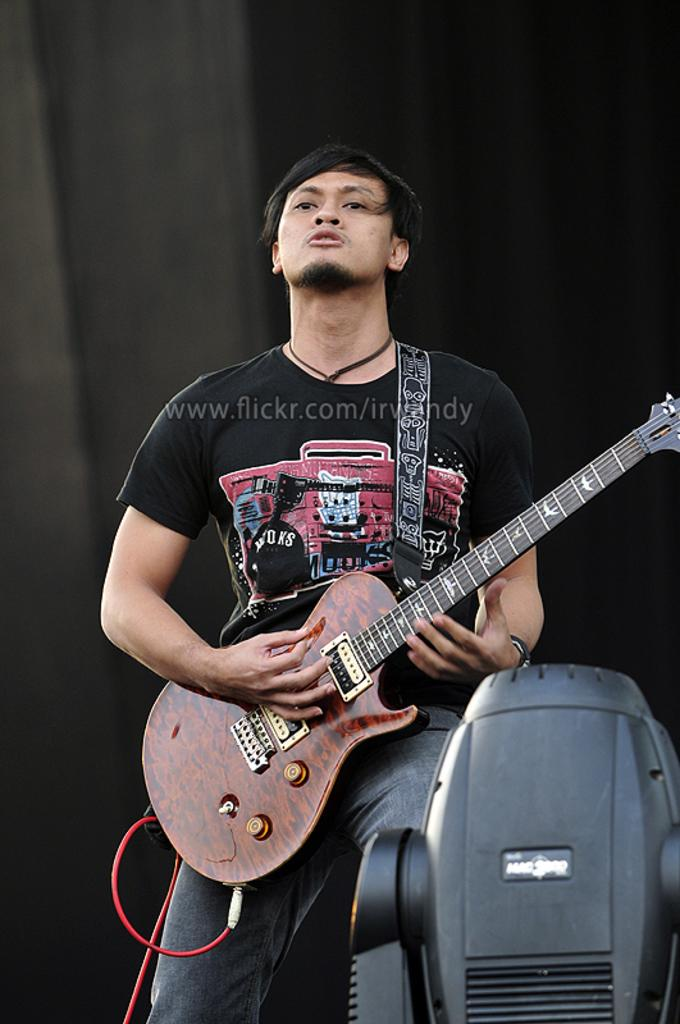What color is the cloth in the background of the image? The cloth in the background of the image is black. What is the man in the image doing? The man in the image is playing a guitar. What is the man wearing in the image? The man is wearing a black color t-shirt. What type of creature is sitting on the guitar in the image? There is no creature sitting on the guitar in the image; the man is playing the guitar by himself. What is the tin used for in the image? There is no tin present in the image. 